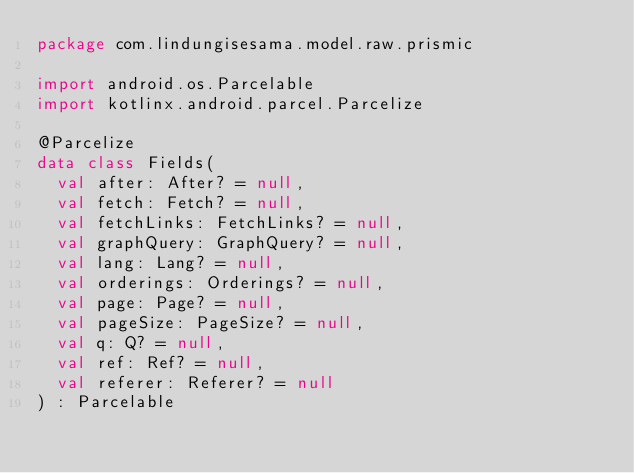<code> <loc_0><loc_0><loc_500><loc_500><_Kotlin_>package com.lindungisesama.model.raw.prismic

import android.os.Parcelable
import kotlinx.android.parcel.Parcelize

@Parcelize
data class Fields(
	val after: After? = null,
	val fetch: Fetch? = null,
	val fetchLinks: FetchLinks? = null,
	val graphQuery: GraphQuery? = null,
	val lang: Lang? = null,
	val orderings: Orderings? = null,
	val page: Page? = null,
	val pageSize: PageSize? = null,
	val q: Q? = null,
	val ref: Ref? = null,
	val referer: Referer? = null
) : Parcelable</code> 